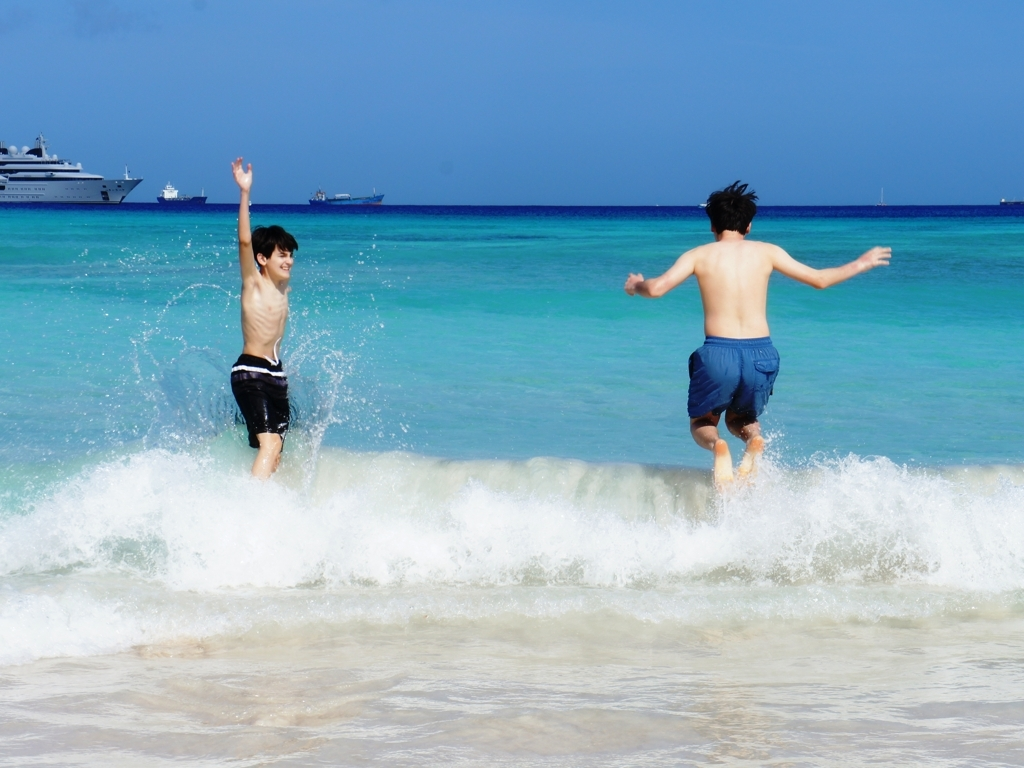Are there any quality issues with this image? The image is generally of good quality with proper focus, rich colors, and adequate lighting. However, there might be a slight motion blur, especially around the subjects, due to their rapid movement, which may be considered a minor quality issue depending on the intention of the photograph. 